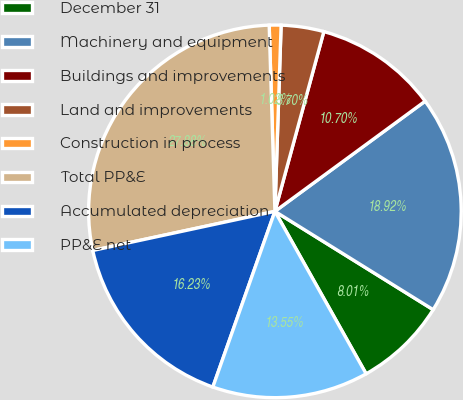<chart> <loc_0><loc_0><loc_500><loc_500><pie_chart><fcel>December 31<fcel>Machinery and equipment<fcel>Buildings and improvements<fcel>Land and improvements<fcel>Construction in process<fcel>Total PP&E<fcel>Accumulated depreciation<fcel>PP&E net<nl><fcel>8.01%<fcel>18.92%<fcel>10.7%<fcel>3.7%<fcel>1.02%<fcel>27.88%<fcel>16.23%<fcel>13.55%<nl></chart> 